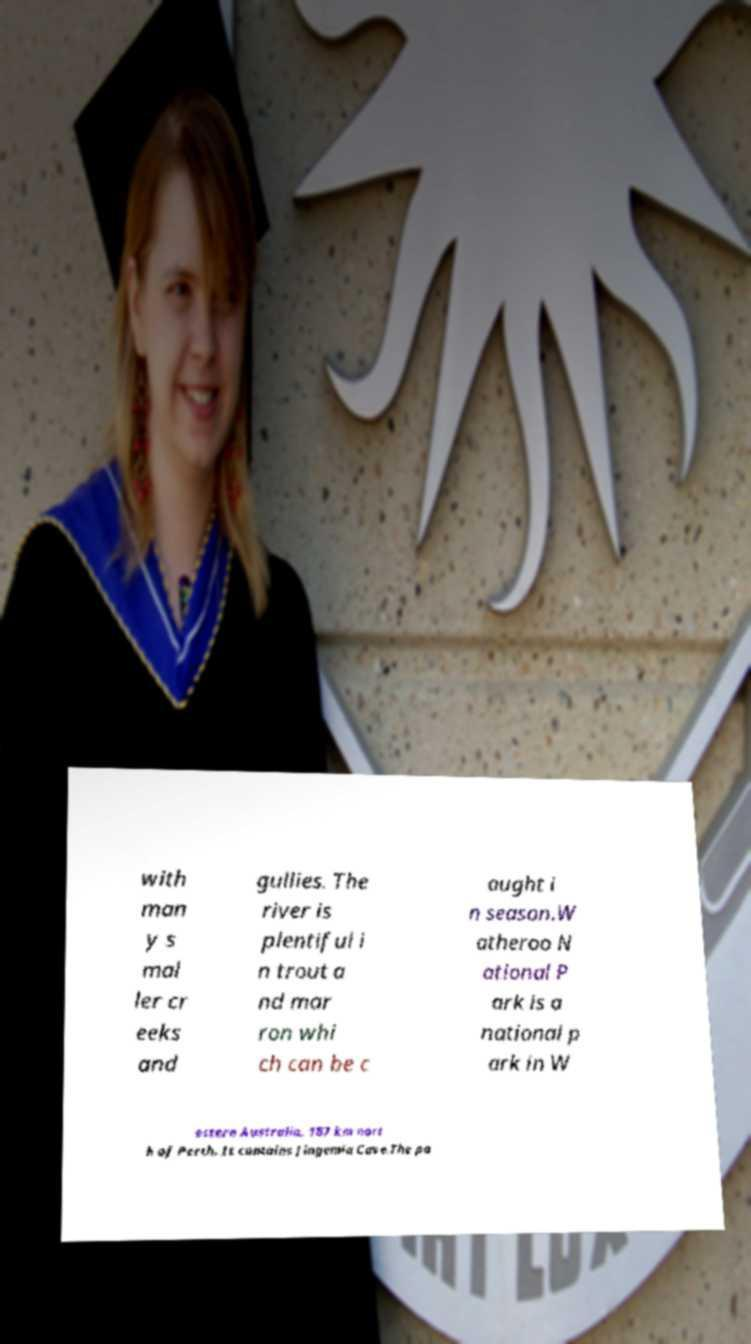There's text embedded in this image that I need extracted. Can you transcribe it verbatim? with man y s mal ler cr eeks and gullies. The river is plentiful i n trout a nd mar ron whi ch can be c aught i n season.W atheroo N ational P ark is a national p ark in W estern Australia, 187 km nort h of Perth. It contains Jingemia Cave.The pa 